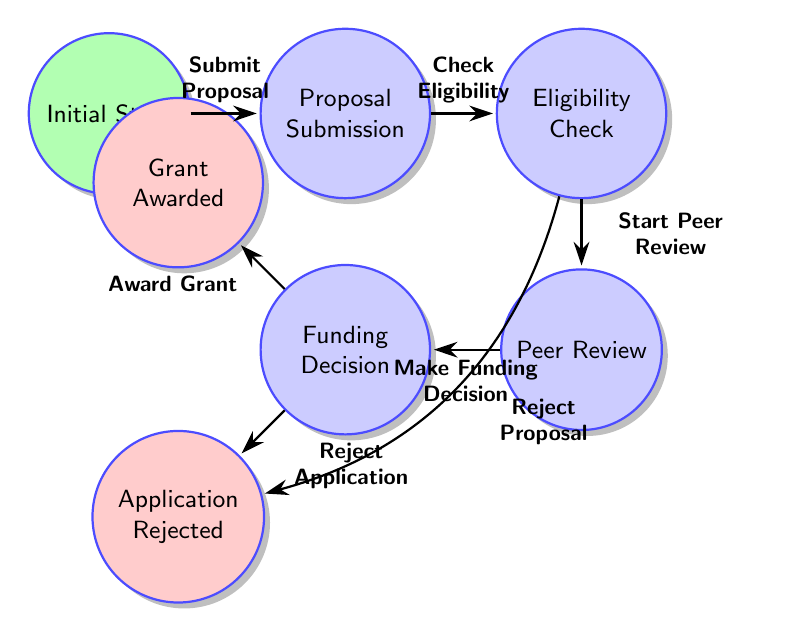What is the initial state of the process? The diagram indicates that the initial state is "Initial State." This is explicitly labeled in the diagram and serves as the starting point of the process.
Answer: Initial State How many nodes are in the diagram? By counting all distinct states shown in the diagram, there are a total of 7 nodes: Initial State, Proposal Submission, Eligibility Check, Peer Review, Funding Decision, Grant Awarded, and Application Rejected.
Answer: 7 Which state follows the "Proposal Submission"? The diagram shows that after "Proposal Submission," the next state is "Eligibility Check," connected by an arrow indicating the transition from one state to the next.
Answer: Eligibility Check What happens if the proposal does not meet eligibility criteria? According to the diagram, if the proposal does not meet eligibility criteria, the transition leads to "Application Rejected," indicating that the application is declined.
Answer: Application Rejected What is the final state if the grant is awarded? The diagram identifies "Grant Awarded" as a final state, meaning that this node represents the conclusion of the process if the funding decision is positive.
Answer: Grant Awarded What transitions lead to the "Application Rejected" state? The diagram shows two transitions leading to "Application Rejected": one from "Eligibility Check" (if the proposal does not meet eligibility criteria) and one from "Funding Decision" (if the negative funding decision is made based on reviews).
Answer: Eligibility Check, Funding Decision What is the outcome if the peer review is not completed after "Peer Review"? The diagram does not explicitly state what occurs if peer review is not completed; however, it infers that this state is necessary to progress to the "Funding Decision," suggesting no direct transition leads from "Peer Review" without completion.
Answer: No outcome indicated How does one progress from "Funding Decision" to "Grant Awarded"? The transition from "Funding Decision" to "Grant Awarded" occurs when there is a "Positive funding decision made based on reviews," as indicated on the corresponding arrow connecting these states.
Answer: Positive funding decision What is required to start the "Peer Review"? The diagram specifies that "Start Peer Review" requires the proposal to meet eligibility criteria, which must be verified in the previous state "Eligibility Check."
Answer: Proposal meets eligibility criteria 